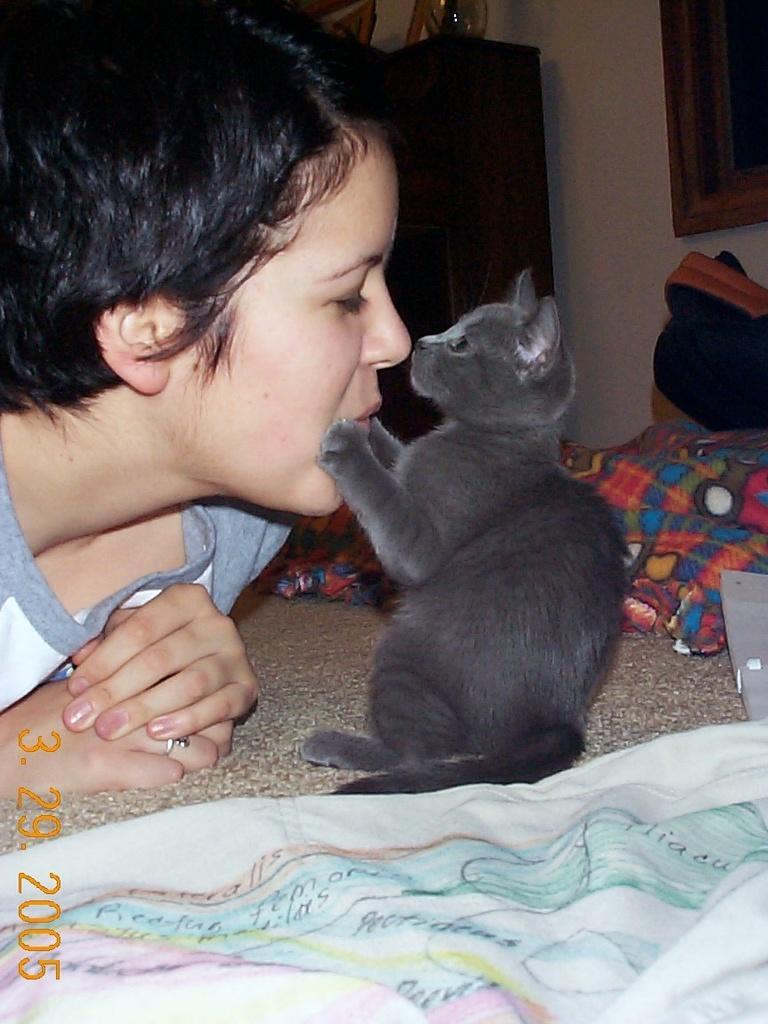Could you give a brief overview of what you see in this image? In the foreground of this image, there is a black cat and a woman on a bed. On the bottom of the image, there is a white cloth and in the background, there is a blanket on bed, the wall, and the cupboard. 